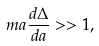Convert formula to latex. <formula><loc_0><loc_0><loc_500><loc_500>m a \frac { d \Delta } { d a } > > 1 ,</formula> 